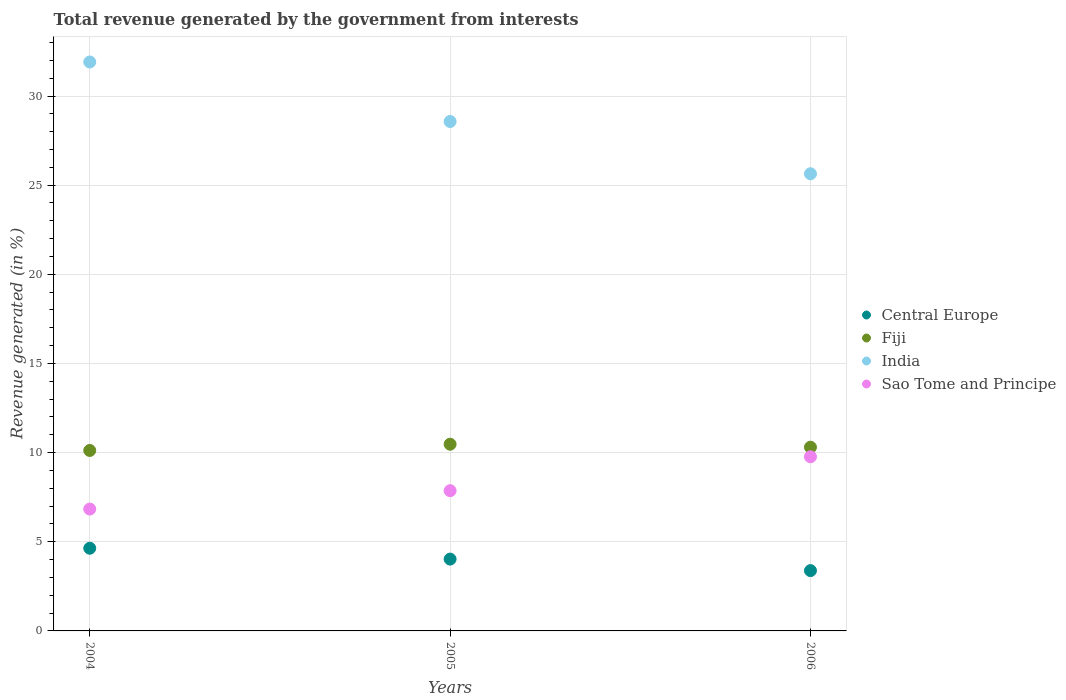How many different coloured dotlines are there?
Your answer should be compact. 4. Is the number of dotlines equal to the number of legend labels?
Give a very brief answer. Yes. What is the total revenue generated in Sao Tome and Principe in 2006?
Ensure brevity in your answer.  9.77. Across all years, what is the maximum total revenue generated in Fiji?
Provide a short and direct response. 10.47. Across all years, what is the minimum total revenue generated in India?
Offer a terse response. 25.64. What is the total total revenue generated in Central Europe in the graph?
Offer a terse response. 12.05. What is the difference between the total revenue generated in India in 2005 and that in 2006?
Make the answer very short. 2.93. What is the difference between the total revenue generated in Sao Tome and Principe in 2004 and the total revenue generated in Central Europe in 2005?
Ensure brevity in your answer.  2.81. What is the average total revenue generated in Fiji per year?
Give a very brief answer. 10.3. In the year 2004, what is the difference between the total revenue generated in India and total revenue generated in Fiji?
Make the answer very short. 21.79. In how many years, is the total revenue generated in Central Europe greater than 14 %?
Provide a succinct answer. 0. What is the ratio of the total revenue generated in Fiji in 2004 to that in 2006?
Provide a short and direct response. 0.98. Is the difference between the total revenue generated in India in 2004 and 2005 greater than the difference between the total revenue generated in Fiji in 2004 and 2005?
Your answer should be compact. Yes. What is the difference between the highest and the second highest total revenue generated in Central Europe?
Keep it short and to the point. 0.61. What is the difference between the highest and the lowest total revenue generated in Fiji?
Your answer should be compact. 0.35. In how many years, is the total revenue generated in Fiji greater than the average total revenue generated in Fiji taken over all years?
Provide a succinct answer. 2. Is the sum of the total revenue generated in Central Europe in 2004 and 2006 greater than the maximum total revenue generated in India across all years?
Offer a terse response. No. Is it the case that in every year, the sum of the total revenue generated in Sao Tome and Principe and total revenue generated in Central Europe  is greater than the total revenue generated in Fiji?
Ensure brevity in your answer.  Yes. Is the total revenue generated in Sao Tome and Principe strictly greater than the total revenue generated in Fiji over the years?
Offer a very short reply. No. How many dotlines are there?
Your response must be concise. 4. What is the difference between two consecutive major ticks on the Y-axis?
Make the answer very short. 5. Does the graph contain any zero values?
Offer a terse response. No. Does the graph contain grids?
Make the answer very short. Yes. How are the legend labels stacked?
Offer a very short reply. Vertical. What is the title of the graph?
Your answer should be very brief. Total revenue generated by the government from interests. What is the label or title of the X-axis?
Your response must be concise. Years. What is the label or title of the Y-axis?
Make the answer very short. Revenue generated (in %). What is the Revenue generated (in %) in Central Europe in 2004?
Your answer should be compact. 4.64. What is the Revenue generated (in %) in Fiji in 2004?
Offer a terse response. 10.12. What is the Revenue generated (in %) of India in 2004?
Offer a terse response. 31.91. What is the Revenue generated (in %) of Sao Tome and Principe in 2004?
Offer a very short reply. 6.83. What is the Revenue generated (in %) of Central Europe in 2005?
Provide a short and direct response. 4.03. What is the Revenue generated (in %) of Fiji in 2005?
Your answer should be very brief. 10.47. What is the Revenue generated (in %) of India in 2005?
Give a very brief answer. 28.57. What is the Revenue generated (in %) of Sao Tome and Principe in 2005?
Keep it short and to the point. 7.87. What is the Revenue generated (in %) of Central Europe in 2006?
Keep it short and to the point. 3.38. What is the Revenue generated (in %) of Fiji in 2006?
Your response must be concise. 10.3. What is the Revenue generated (in %) of India in 2006?
Provide a succinct answer. 25.64. What is the Revenue generated (in %) of Sao Tome and Principe in 2006?
Your answer should be compact. 9.77. Across all years, what is the maximum Revenue generated (in %) in Central Europe?
Give a very brief answer. 4.64. Across all years, what is the maximum Revenue generated (in %) of Fiji?
Ensure brevity in your answer.  10.47. Across all years, what is the maximum Revenue generated (in %) of India?
Your answer should be compact. 31.91. Across all years, what is the maximum Revenue generated (in %) in Sao Tome and Principe?
Make the answer very short. 9.77. Across all years, what is the minimum Revenue generated (in %) of Central Europe?
Provide a succinct answer. 3.38. Across all years, what is the minimum Revenue generated (in %) of Fiji?
Your response must be concise. 10.12. Across all years, what is the minimum Revenue generated (in %) of India?
Your response must be concise. 25.64. Across all years, what is the minimum Revenue generated (in %) in Sao Tome and Principe?
Give a very brief answer. 6.83. What is the total Revenue generated (in %) in Central Europe in the graph?
Your response must be concise. 12.05. What is the total Revenue generated (in %) in Fiji in the graph?
Provide a short and direct response. 30.9. What is the total Revenue generated (in %) of India in the graph?
Your answer should be very brief. 86.12. What is the total Revenue generated (in %) in Sao Tome and Principe in the graph?
Your answer should be very brief. 24.47. What is the difference between the Revenue generated (in %) in Central Europe in 2004 and that in 2005?
Keep it short and to the point. 0.61. What is the difference between the Revenue generated (in %) in Fiji in 2004 and that in 2005?
Provide a short and direct response. -0.35. What is the difference between the Revenue generated (in %) in India in 2004 and that in 2005?
Give a very brief answer. 3.34. What is the difference between the Revenue generated (in %) of Sao Tome and Principe in 2004 and that in 2005?
Your answer should be very brief. -1.03. What is the difference between the Revenue generated (in %) of Central Europe in 2004 and that in 2006?
Your answer should be very brief. 1.26. What is the difference between the Revenue generated (in %) in Fiji in 2004 and that in 2006?
Provide a succinct answer. -0.18. What is the difference between the Revenue generated (in %) in India in 2004 and that in 2006?
Offer a terse response. 6.27. What is the difference between the Revenue generated (in %) of Sao Tome and Principe in 2004 and that in 2006?
Provide a succinct answer. -2.93. What is the difference between the Revenue generated (in %) of Central Europe in 2005 and that in 2006?
Your response must be concise. 0.65. What is the difference between the Revenue generated (in %) of Fiji in 2005 and that in 2006?
Provide a short and direct response. 0.17. What is the difference between the Revenue generated (in %) of India in 2005 and that in 2006?
Ensure brevity in your answer.  2.93. What is the difference between the Revenue generated (in %) of Sao Tome and Principe in 2005 and that in 2006?
Provide a succinct answer. -1.9. What is the difference between the Revenue generated (in %) of Central Europe in 2004 and the Revenue generated (in %) of Fiji in 2005?
Give a very brief answer. -5.83. What is the difference between the Revenue generated (in %) of Central Europe in 2004 and the Revenue generated (in %) of India in 2005?
Provide a succinct answer. -23.93. What is the difference between the Revenue generated (in %) in Central Europe in 2004 and the Revenue generated (in %) in Sao Tome and Principe in 2005?
Give a very brief answer. -3.23. What is the difference between the Revenue generated (in %) in Fiji in 2004 and the Revenue generated (in %) in India in 2005?
Offer a very short reply. -18.45. What is the difference between the Revenue generated (in %) of Fiji in 2004 and the Revenue generated (in %) of Sao Tome and Principe in 2005?
Provide a short and direct response. 2.26. What is the difference between the Revenue generated (in %) in India in 2004 and the Revenue generated (in %) in Sao Tome and Principe in 2005?
Keep it short and to the point. 24.04. What is the difference between the Revenue generated (in %) of Central Europe in 2004 and the Revenue generated (in %) of Fiji in 2006?
Make the answer very short. -5.67. What is the difference between the Revenue generated (in %) in Central Europe in 2004 and the Revenue generated (in %) in India in 2006?
Provide a succinct answer. -21. What is the difference between the Revenue generated (in %) in Central Europe in 2004 and the Revenue generated (in %) in Sao Tome and Principe in 2006?
Provide a succinct answer. -5.13. What is the difference between the Revenue generated (in %) in Fiji in 2004 and the Revenue generated (in %) in India in 2006?
Keep it short and to the point. -15.52. What is the difference between the Revenue generated (in %) in Fiji in 2004 and the Revenue generated (in %) in Sao Tome and Principe in 2006?
Keep it short and to the point. 0.35. What is the difference between the Revenue generated (in %) of India in 2004 and the Revenue generated (in %) of Sao Tome and Principe in 2006?
Your answer should be very brief. 22.14. What is the difference between the Revenue generated (in %) of Central Europe in 2005 and the Revenue generated (in %) of Fiji in 2006?
Provide a succinct answer. -6.28. What is the difference between the Revenue generated (in %) of Central Europe in 2005 and the Revenue generated (in %) of India in 2006?
Your answer should be very brief. -21.61. What is the difference between the Revenue generated (in %) in Central Europe in 2005 and the Revenue generated (in %) in Sao Tome and Principe in 2006?
Keep it short and to the point. -5.74. What is the difference between the Revenue generated (in %) in Fiji in 2005 and the Revenue generated (in %) in India in 2006?
Give a very brief answer. -15.17. What is the difference between the Revenue generated (in %) of Fiji in 2005 and the Revenue generated (in %) of Sao Tome and Principe in 2006?
Offer a very short reply. 0.7. What is the difference between the Revenue generated (in %) in India in 2005 and the Revenue generated (in %) in Sao Tome and Principe in 2006?
Your answer should be very brief. 18.8. What is the average Revenue generated (in %) in Central Europe per year?
Give a very brief answer. 4.02. What is the average Revenue generated (in %) of Fiji per year?
Ensure brevity in your answer.  10.3. What is the average Revenue generated (in %) in India per year?
Your answer should be very brief. 28.71. What is the average Revenue generated (in %) in Sao Tome and Principe per year?
Provide a succinct answer. 8.16. In the year 2004, what is the difference between the Revenue generated (in %) of Central Europe and Revenue generated (in %) of Fiji?
Offer a terse response. -5.48. In the year 2004, what is the difference between the Revenue generated (in %) in Central Europe and Revenue generated (in %) in India?
Keep it short and to the point. -27.27. In the year 2004, what is the difference between the Revenue generated (in %) in Central Europe and Revenue generated (in %) in Sao Tome and Principe?
Provide a succinct answer. -2.2. In the year 2004, what is the difference between the Revenue generated (in %) of Fiji and Revenue generated (in %) of India?
Your answer should be compact. -21.79. In the year 2004, what is the difference between the Revenue generated (in %) of Fiji and Revenue generated (in %) of Sao Tome and Principe?
Ensure brevity in your answer.  3.29. In the year 2004, what is the difference between the Revenue generated (in %) of India and Revenue generated (in %) of Sao Tome and Principe?
Your answer should be compact. 25.07. In the year 2005, what is the difference between the Revenue generated (in %) in Central Europe and Revenue generated (in %) in Fiji?
Give a very brief answer. -6.44. In the year 2005, what is the difference between the Revenue generated (in %) of Central Europe and Revenue generated (in %) of India?
Your answer should be compact. -24.54. In the year 2005, what is the difference between the Revenue generated (in %) of Central Europe and Revenue generated (in %) of Sao Tome and Principe?
Offer a very short reply. -3.84. In the year 2005, what is the difference between the Revenue generated (in %) in Fiji and Revenue generated (in %) in India?
Ensure brevity in your answer.  -18.1. In the year 2005, what is the difference between the Revenue generated (in %) of Fiji and Revenue generated (in %) of Sao Tome and Principe?
Make the answer very short. 2.61. In the year 2005, what is the difference between the Revenue generated (in %) in India and Revenue generated (in %) in Sao Tome and Principe?
Offer a very short reply. 20.71. In the year 2006, what is the difference between the Revenue generated (in %) in Central Europe and Revenue generated (in %) in Fiji?
Make the answer very short. -6.92. In the year 2006, what is the difference between the Revenue generated (in %) of Central Europe and Revenue generated (in %) of India?
Your answer should be very brief. -22.26. In the year 2006, what is the difference between the Revenue generated (in %) in Central Europe and Revenue generated (in %) in Sao Tome and Principe?
Your response must be concise. -6.39. In the year 2006, what is the difference between the Revenue generated (in %) of Fiji and Revenue generated (in %) of India?
Your response must be concise. -15.34. In the year 2006, what is the difference between the Revenue generated (in %) in Fiji and Revenue generated (in %) in Sao Tome and Principe?
Offer a very short reply. 0.54. In the year 2006, what is the difference between the Revenue generated (in %) in India and Revenue generated (in %) in Sao Tome and Principe?
Provide a succinct answer. 15.87. What is the ratio of the Revenue generated (in %) of Central Europe in 2004 to that in 2005?
Provide a short and direct response. 1.15. What is the ratio of the Revenue generated (in %) of Fiji in 2004 to that in 2005?
Keep it short and to the point. 0.97. What is the ratio of the Revenue generated (in %) of India in 2004 to that in 2005?
Your response must be concise. 1.12. What is the ratio of the Revenue generated (in %) of Sao Tome and Principe in 2004 to that in 2005?
Your answer should be very brief. 0.87. What is the ratio of the Revenue generated (in %) of Central Europe in 2004 to that in 2006?
Provide a succinct answer. 1.37. What is the ratio of the Revenue generated (in %) of Fiji in 2004 to that in 2006?
Make the answer very short. 0.98. What is the ratio of the Revenue generated (in %) of India in 2004 to that in 2006?
Your answer should be very brief. 1.24. What is the ratio of the Revenue generated (in %) of Sao Tome and Principe in 2004 to that in 2006?
Offer a terse response. 0.7. What is the ratio of the Revenue generated (in %) in Central Europe in 2005 to that in 2006?
Your answer should be compact. 1.19. What is the ratio of the Revenue generated (in %) in Fiji in 2005 to that in 2006?
Your response must be concise. 1.02. What is the ratio of the Revenue generated (in %) in India in 2005 to that in 2006?
Ensure brevity in your answer.  1.11. What is the ratio of the Revenue generated (in %) in Sao Tome and Principe in 2005 to that in 2006?
Provide a short and direct response. 0.81. What is the difference between the highest and the second highest Revenue generated (in %) of Central Europe?
Keep it short and to the point. 0.61. What is the difference between the highest and the second highest Revenue generated (in %) of Fiji?
Your answer should be compact. 0.17. What is the difference between the highest and the second highest Revenue generated (in %) of India?
Provide a short and direct response. 3.34. What is the difference between the highest and the second highest Revenue generated (in %) of Sao Tome and Principe?
Your answer should be very brief. 1.9. What is the difference between the highest and the lowest Revenue generated (in %) of Central Europe?
Keep it short and to the point. 1.26. What is the difference between the highest and the lowest Revenue generated (in %) in Fiji?
Offer a terse response. 0.35. What is the difference between the highest and the lowest Revenue generated (in %) in India?
Offer a very short reply. 6.27. What is the difference between the highest and the lowest Revenue generated (in %) of Sao Tome and Principe?
Your answer should be very brief. 2.93. 